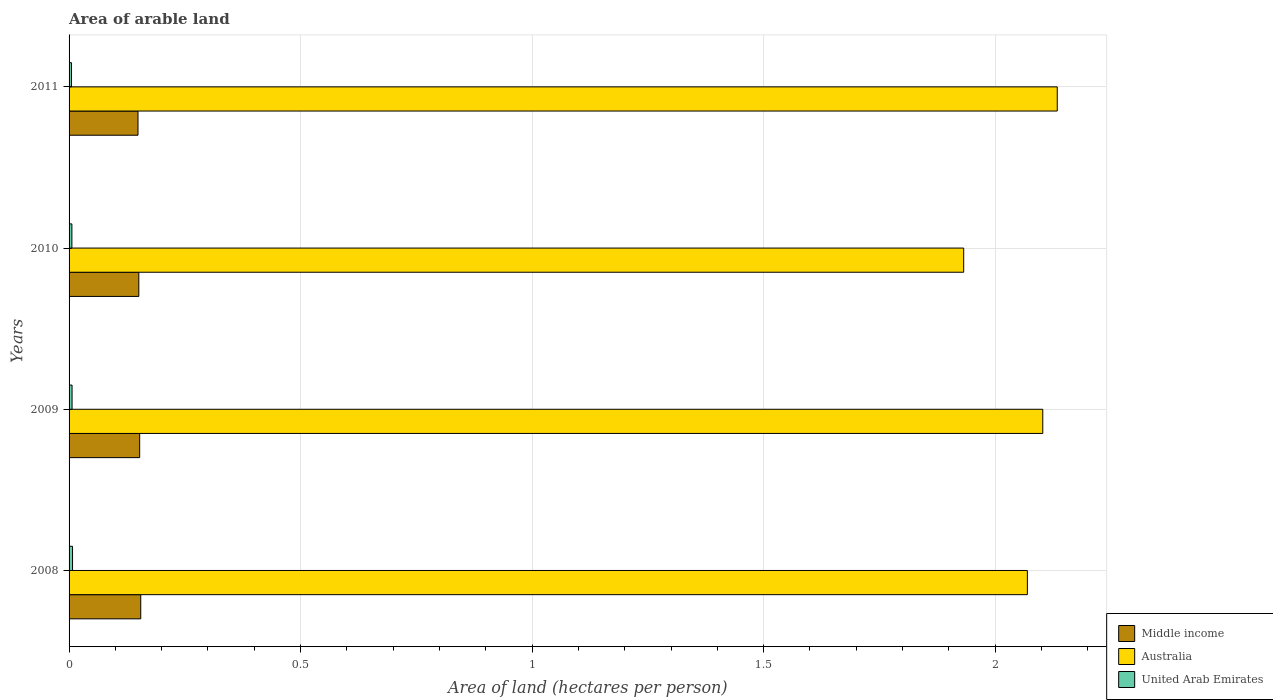How many different coloured bars are there?
Make the answer very short. 3. Are the number of bars per tick equal to the number of legend labels?
Your answer should be compact. Yes. How many bars are there on the 2nd tick from the top?
Ensure brevity in your answer.  3. How many bars are there on the 2nd tick from the bottom?
Give a very brief answer. 3. In how many cases, is the number of bars for a given year not equal to the number of legend labels?
Your response must be concise. 0. What is the total arable land in United Arab Emirates in 2008?
Your response must be concise. 0.01. Across all years, what is the maximum total arable land in Australia?
Offer a very short reply. 2.13. Across all years, what is the minimum total arable land in United Arab Emirates?
Your response must be concise. 0.01. In which year was the total arable land in United Arab Emirates maximum?
Your response must be concise. 2008. In which year was the total arable land in Australia minimum?
Offer a terse response. 2010. What is the total total arable land in Middle income in the graph?
Your answer should be compact. 0.61. What is the difference between the total arable land in Middle income in 2008 and that in 2009?
Give a very brief answer. 0. What is the difference between the total arable land in Middle income in 2011 and the total arable land in Australia in 2008?
Give a very brief answer. -1.92. What is the average total arable land in Middle income per year?
Your answer should be compact. 0.15. In the year 2009, what is the difference between the total arable land in Middle income and total arable land in United Arab Emirates?
Keep it short and to the point. 0.15. What is the ratio of the total arable land in Australia in 2009 to that in 2010?
Ensure brevity in your answer.  1.09. Is the total arable land in Middle income in 2008 less than that in 2009?
Provide a succinct answer. No. Is the difference between the total arable land in Middle income in 2008 and 2010 greater than the difference between the total arable land in United Arab Emirates in 2008 and 2010?
Your answer should be compact. Yes. What is the difference between the highest and the second highest total arable land in Australia?
Keep it short and to the point. 0.03. What is the difference between the highest and the lowest total arable land in United Arab Emirates?
Offer a terse response. 0. In how many years, is the total arable land in Australia greater than the average total arable land in Australia taken over all years?
Your answer should be compact. 3. Is the sum of the total arable land in Middle income in 2010 and 2011 greater than the maximum total arable land in United Arab Emirates across all years?
Offer a terse response. Yes. What does the 1st bar from the top in 2009 represents?
Your answer should be compact. United Arab Emirates. What does the 3rd bar from the bottom in 2011 represents?
Offer a very short reply. United Arab Emirates. Is it the case that in every year, the sum of the total arable land in Australia and total arable land in Middle income is greater than the total arable land in United Arab Emirates?
Provide a succinct answer. Yes. How many years are there in the graph?
Make the answer very short. 4. Does the graph contain any zero values?
Offer a very short reply. No. How many legend labels are there?
Give a very brief answer. 3. What is the title of the graph?
Provide a succinct answer. Area of arable land. What is the label or title of the X-axis?
Offer a very short reply. Area of land (hectares per person). What is the Area of land (hectares per person) in Middle income in 2008?
Offer a very short reply. 0.15. What is the Area of land (hectares per person) in Australia in 2008?
Your answer should be compact. 2.07. What is the Area of land (hectares per person) of United Arab Emirates in 2008?
Provide a succinct answer. 0.01. What is the Area of land (hectares per person) of Middle income in 2009?
Offer a terse response. 0.15. What is the Area of land (hectares per person) of Australia in 2009?
Your answer should be compact. 2.1. What is the Area of land (hectares per person) of United Arab Emirates in 2009?
Offer a terse response. 0.01. What is the Area of land (hectares per person) of Middle income in 2010?
Give a very brief answer. 0.15. What is the Area of land (hectares per person) of Australia in 2010?
Provide a succinct answer. 1.93. What is the Area of land (hectares per person) of United Arab Emirates in 2010?
Make the answer very short. 0.01. What is the Area of land (hectares per person) in Middle income in 2011?
Provide a succinct answer. 0.15. What is the Area of land (hectares per person) of Australia in 2011?
Your answer should be very brief. 2.13. What is the Area of land (hectares per person) in United Arab Emirates in 2011?
Offer a very short reply. 0.01. Across all years, what is the maximum Area of land (hectares per person) of Middle income?
Give a very brief answer. 0.15. Across all years, what is the maximum Area of land (hectares per person) of Australia?
Your response must be concise. 2.13. Across all years, what is the maximum Area of land (hectares per person) in United Arab Emirates?
Make the answer very short. 0.01. Across all years, what is the minimum Area of land (hectares per person) in Middle income?
Provide a succinct answer. 0.15. Across all years, what is the minimum Area of land (hectares per person) of Australia?
Keep it short and to the point. 1.93. Across all years, what is the minimum Area of land (hectares per person) in United Arab Emirates?
Your response must be concise. 0.01. What is the total Area of land (hectares per person) in Middle income in the graph?
Provide a succinct answer. 0.61. What is the total Area of land (hectares per person) in Australia in the graph?
Offer a terse response. 8.24. What is the total Area of land (hectares per person) of United Arab Emirates in the graph?
Provide a short and direct response. 0.03. What is the difference between the Area of land (hectares per person) of Middle income in 2008 and that in 2009?
Your answer should be compact. 0. What is the difference between the Area of land (hectares per person) in Australia in 2008 and that in 2009?
Provide a short and direct response. -0.03. What is the difference between the Area of land (hectares per person) of Middle income in 2008 and that in 2010?
Ensure brevity in your answer.  0. What is the difference between the Area of land (hectares per person) of Australia in 2008 and that in 2010?
Keep it short and to the point. 0.14. What is the difference between the Area of land (hectares per person) of United Arab Emirates in 2008 and that in 2010?
Offer a very short reply. 0. What is the difference between the Area of land (hectares per person) of Middle income in 2008 and that in 2011?
Provide a succinct answer. 0.01. What is the difference between the Area of land (hectares per person) of Australia in 2008 and that in 2011?
Offer a terse response. -0.06. What is the difference between the Area of land (hectares per person) in United Arab Emirates in 2008 and that in 2011?
Give a very brief answer. 0. What is the difference between the Area of land (hectares per person) of Middle income in 2009 and that in 2010?
Your answer should be compact. 0. What is the difference between the Area of land (hectares per person) in Australia in 2009 and that in 2010?
Make the answer very short. 0.17. What is the difference between the Area of land (hectares per person) of United Arab Emirates in 2009 and that in 2010?
Give a very brief answer. 0. What is the difference between the Area of land (hectares per person) of Middle income in 2009 and that in 2011?
Your response must be concise. 0. What is the difference between the Area of land (hectares per person) of Australia in 2009 and that in 2011?
Keep it short and to the point. -0.03. What is the difference between the Area of land (hectares per person) of United Arab Emirates in 2009 and that in 2011?
Offer a very short reply. 0. What is the difference between the Area of land (hectares per person) of Middle income in 2010 and that in 2011?
Provide a short and direct response. 0. What is the difference between the Area of land (hectares per person) of Australia in 2010 and that in 2011?
Ensure brevity in your answer.  -0.2. What is the difference between the Area of land (hectares per person) of United Arab Emirates in 2010 and that in 2011?
Provide a succinct answer. 0. What is the difference between the Area of land (hectares per person) in Middle income in 2008 and the Area of land (hectares per person) in Australia in 2009?
Offer a terse response. -1.95. What is the difference between the Area of land (hectares per person) in Middle income in 2008 and the Area of land (hectares per person) in United Arab Emirates in 2009?
Offer a terse response. 0.15. What is the difference between the Area of land (hectares per person) of Australia in 2008 and the Area of land (hectares per person) of United Arab Emirates in 2009?
Your answer should be compact. 2.06. What is the difference between the Area of land (hectares per person) of Middle income in 2008 and the Area of land (hectares per person) of Australia in 2010?
Keep it short and to the point. -1.78. What is the difference between the Area of land (hectares per person) of Middle income in 2008 and the Area of land (hectares per person) of United Arab Emirates in 2010?
Your response must be concise. 0.15. What is the difference between the Area of land (hectares per person) in Australia in 2008 and the Area of land (hectares per person) in United Arab Emirates in 2010?
Provide a short and direct response. 2.06. What is the difference between the Area of land (hectares per person) of Middle income in 2008 and the Area of land (hectares per person) of Australia in 2011?
Your answer should be compact. -1.98. What is the difference between the Area of land (hectares per person) of Middle income in 2008 and the Area of land (hectares per person) of United Arab Emirates in 2011?
Provide a succinct answer. 0.15. What is the difference between the Area of land (hectares per person) in Australia in 2008 and the Area of land (hectares per person) in United Arab Emirates in 2011?
Give a very brief answer. 2.06. What is the difference between the Area of land (hectares per person) in Middle income in 2009 and the Area of land (hectares per person) in Australia in 2010?
Your answer should be compact. -1.78. What is the difference between the Area of land (hectares per person) of Middle income in 2009 and the Area of land (hectares per person) of United Arab Emirates in 2010?
Provide a succinct answer. 0.15. What is the difference between the Area of land (hectares per person) in Australia in 2009 and the Area of land (hectares per person) in United Arab Emirates in 2010?
Provide a succinct answer. 2.1. What is the difference between the Area of land (hectares per person) in Middle income in 2009 and the Area of land (hectares per person) in Australia in 2011?
Offer a very short reply. -1.98. What is the difference between the Area of land (hectares per person) in Middle income in 2009 and the Area of land (hectares per person) in United Arab Emirates in 2011?
Provide a succinct answer. 0.15. What is the difference between the Area of land (hectares per person) in Australia in 2009 and the Area of land (hectares per person) in United Arab Emirates in 2011?
Your answer should be compact. 2.1. What is the difference between the Area of land (hectares per person) of Middle income in 2010 and the Area of land (hectares per person) of Australia in 2011?
Provide a succinct answer. -1.98. What is the difference between the Area of land (hectares per person) of Middle income in 2010 and the Area of land (hectares per person) of United Arab Emirates in 2011?
Make the answer very short. 0.15. What is the difference between the Area of land (hectares per person) of Australia in 2010 and the Area of land (hectares per person) of United Arab Emirates in 2011?
Make the answer very short. 1.93. What is the average Area of land (hectares per person) in Middle income per year?
Ensure brevity in your answer.  0.15. What is the average Area of land (hectares per person) in Australia per year?
Your answer should be compact. 2.06. What is the average Area of land (hectares per person) of United Arab Emirates per year?
Keep it short and to the point. 0.01. In the year 2008, what is the difference between the Area of land (hectares per person) of Middle income and Area of land (hectares per person) of Australia?
Ensure brevity in your answer.  -1.91. In the year 2008, what is the difference between the Area of land (hectares per person) of Middle income and Area of land (hectares per person) of United Arab Emirates?
Give a very brief answer. 0.15. In the year 2008, what is the difference between the Area of land (hectares per person) in Australia and Area of land (hectares per person) in United Arab Emirates?
Provide a succinct answer. 2.06. In the year 2009, what is the difference between the Area of land (hectares per person) of Middle income and Area of land (hectares per person) of Australia?
Your answer should be very brief. -1.95. In the year 2009, what is the difference between the Area of land (hectares per person) in Middle income and Area of land (hectares per person) in United Arab Emirates?
Make the answer very short. 0.15. In the year 2009, what is the difference between the Area of land (hectares per person) in Australia and Area of land (hectares per person) in United Arab Emirates?
Offer a terse response. 2.1. In the year 2010, what is the difference between the Area of land (hectares per person) of Middle income and Area of land (hectares per person) of Australia?
Make the answer very short. -1.78. In the year 2010, what is the difference between the Area of land (hectares per person) in Middle income and Area of land (hectares per person) in United Arab Emirates?
Give a very brief answer. 0.14. In the year 2010, what is the difference between the Area of land (hectares per person) in Australia and Area of land (hectares per person) in United Arab Emirates?
Your answer should be compact. 1.93. In the year 2011, what is the difference between the Area of land (hectares per person) in Middle income and Area of land (hectares per person) in Australia?
Give a very brief answer. -1.99. In the year 2011, what is the difference between the Area of land (hectares per person) of Middle income and Area of land (hectares per person) of United Arab Emirates?
Offer a terse response. 0.14. In the year 2011, what is the difference between the Area of land (hectares per person) in Australia and Area of land (hectares per person) in United Arab Emirates?
Your answer should be compact. 2.13. What is the ratio of the Area of land (hectares per person) in Middle income in 2008 to that in 2009?
Offer a very short reply. 1.02. What is the ratio of the Area of land (hectares per person) of Australia in 2008 to that in 2009?
Your answer should be very brief. 0.98. What is the ratio of the Area of land (hectares per person) in United Arab Emirates in 2008 to that in 2009?
Keep it short and to the point. 1.15. What is the ratio of the Area of land (hectares per person) in Middle income in 2008 to that in 2010?
Your answer should be compact. 1.03. What is the ratio of the Area of land (hectares per person) of Australia in 2008 to that in 2010?
Ensure brevity in your answer.  1.07. What is the ratio of the Area of land (hectares per person) in United Arab Emirates in 2008 to that in 2010?
Keep it short and to the point. 1.23. What is the ratio of the Area of land (hectares per person) of Australia in 2008 to that in 2011?
Make the answer very short. 0.97. What is the ratio of the Area of land (hectares per person) in United Arab Emirates in 2008 to that in 2011?
Give a very brief answer. 1.45. What is the ratio of the Area of land (hectares per person) of Middle income in 2009 to that in 2010?
Ensure brevity in your answer.  1.01. What is the ratio of the Area of land (hectares per person) in Australia in 2009 to that in 2010?
Ensure brevity in your answer.  1.09. What is the ratio of the Area of land (hectares per person) of United Arab Emirates in 2009 to that in 2010?
Give a very brief answer. 1.07. What is the ratio of the Area of land (hectares per person) of Middle income in 2009 to that in 2011?
Your answer should be compact. 1.02. What is the ratio of the Area of land (hectares per person) in United Arab Emirates in 2009 to that in 2011?
Your answer should be compact. 1.25. What is the ratio of the Area of land (hectares per person) in Middle income in 2010 to that in 2011?
Your answer should be very brief. 1.01. What is the ratio of the Area of land (hectares per person) in Australia in 2010 to that in 2011?
Your answer should be very brief. 0.91. What is the ratio of the Area of land (hectares per person) in United Arab Emirates in 2010 to that in 2011?
Offer a very short reply. 1.18. What is the difference between the highest and the second highest Area of land (hectares per person) in Middle income?
Give a very brief answer. 0. What is the difference between the highest and the second highest Area of land (hectares per person) in Australia?
Offer a terse response. 0.03. What is the difference between the highest and the second highest Area of land (hectares per person) of United Arab Emirates?
Make the answer very short. 0. What is the difference between the highest and the lowest Area of land (hectares per person) of Middle income?
Your answer should be very brief. 0.01. What is the difference between the highest and the lowest Area of land (hectares per person) in Australia?
Offer a terse response. 0.2. What is the difference between the highest and the lowest Area of land (hectares per person) in United Arab Emirates?
Provide a succinct answer. 0. 